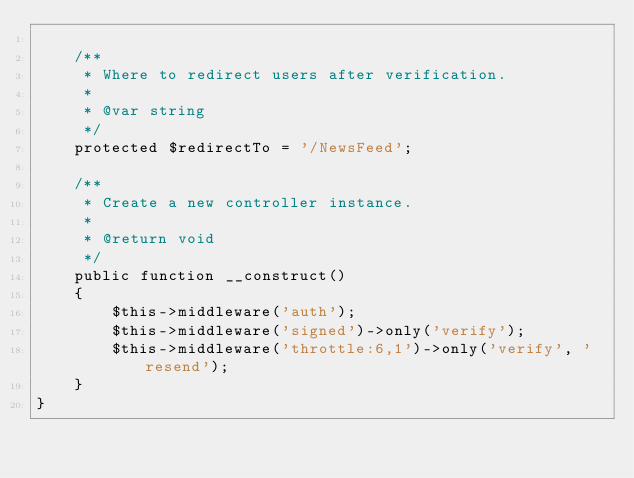<code> <loc_0><loc_0><loc_500><loc_500><_PHP_>
    /**
     * Where to redirect users after verification.
     *
     * @var string
     */
    protected $redirectTo = '/NewsFeed';

    /**
     * Create a new controller instance.
     *
     * @return void
     */
    public function __construct()
    {
        $this->middleware('auth');
        $this->middleware('signed')->only('verify');
        $this->middleware('throttle:6,1')->only('verify', 'resend');
    }
}
</code> 